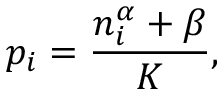Convert formula to latex. <formula><loc_0><loc_0><loc_500><loc_500>p _ { i } = \frac { n _ { i } ^ { \alpha } + \beta } { K } ,</formula> 